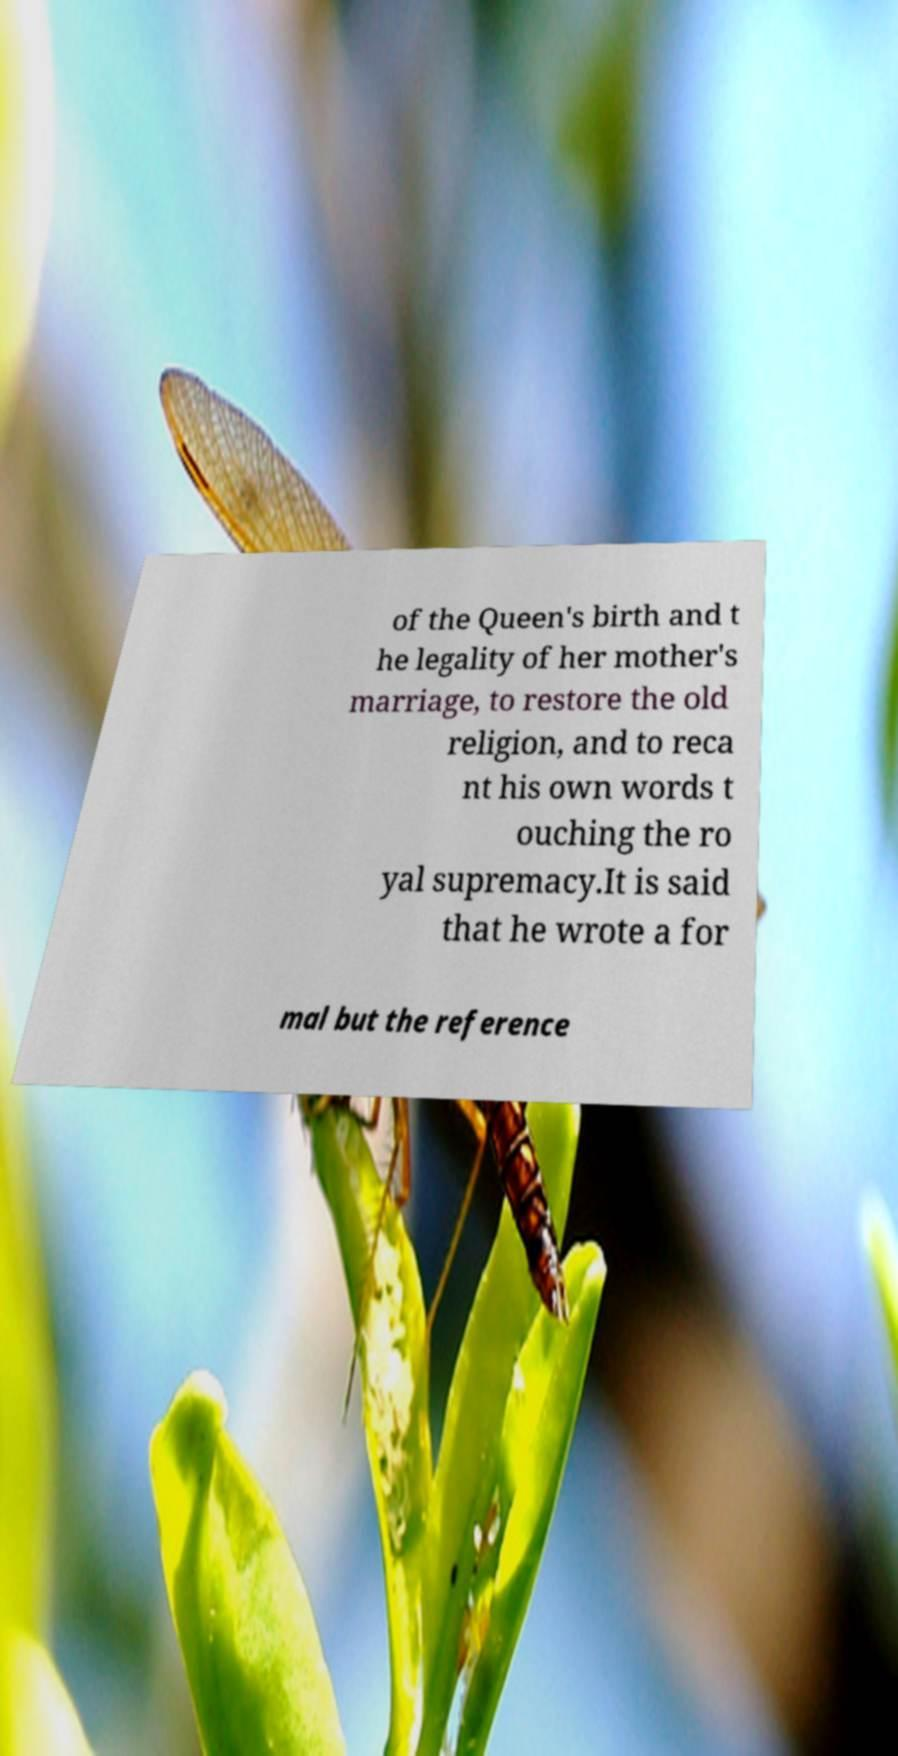Can you accurately transcribe the text from the provided image for me? of the Queen's birth and t he legality of her mother's marriage, to restore the old religion, and to reca nt his own words t ouching the ro yal supremacy.It is said that he wrote a for mal but the reference 